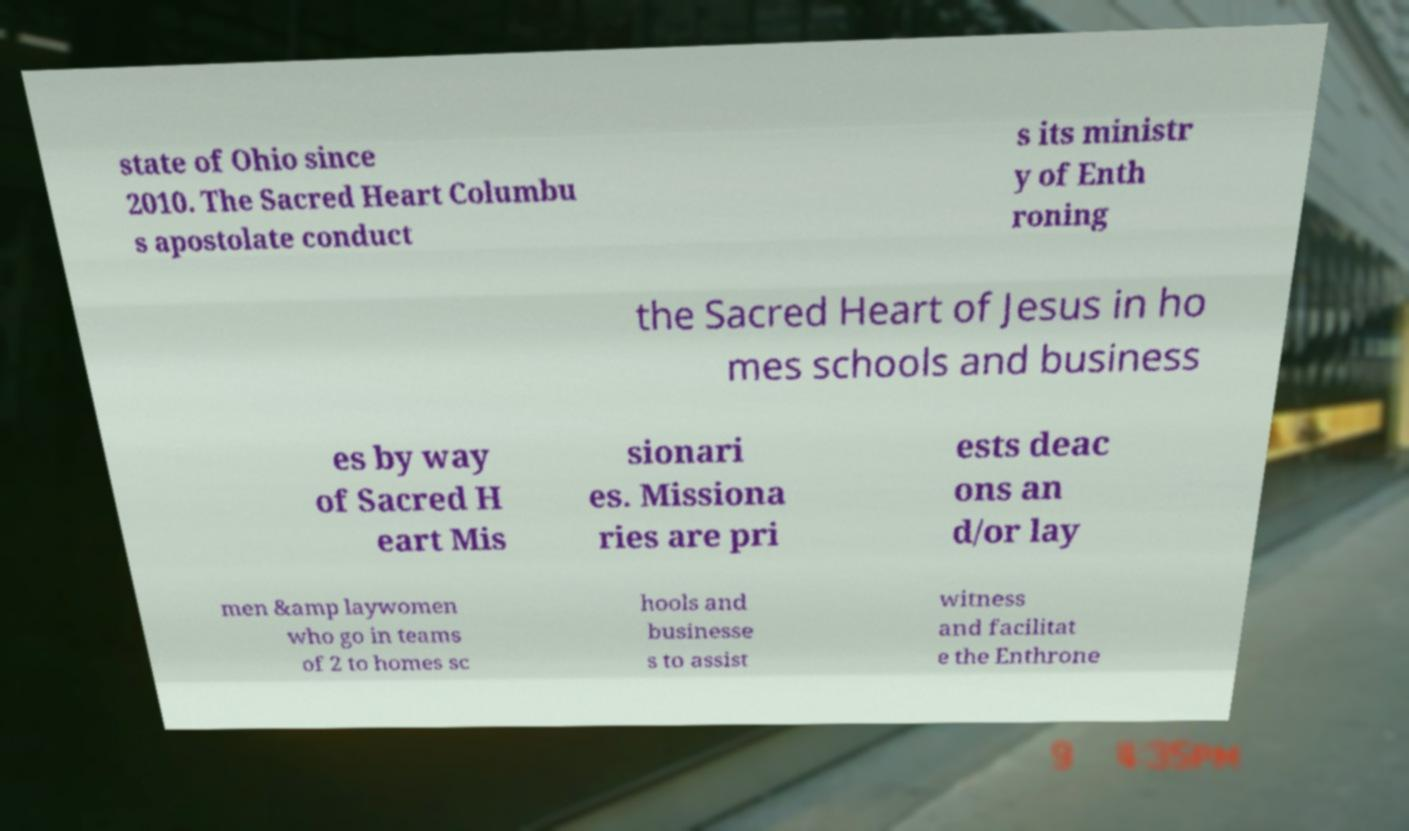Please identify and transcribe the text found in this image. state of Ohio since 2010. The Sacred Heart Columbu s apostolate conduct s its ministr y of Enth roning the Sacred Heart of Jesus in ho mes schools and business es by way of Sacred H eart Mis sionari es. Missiona ries are pri ests deac ons an d/or lay men &amp laywomen who go in teams of 2 to homes sc hools and businesse s to assist witness and facilitat e the Enthrone 